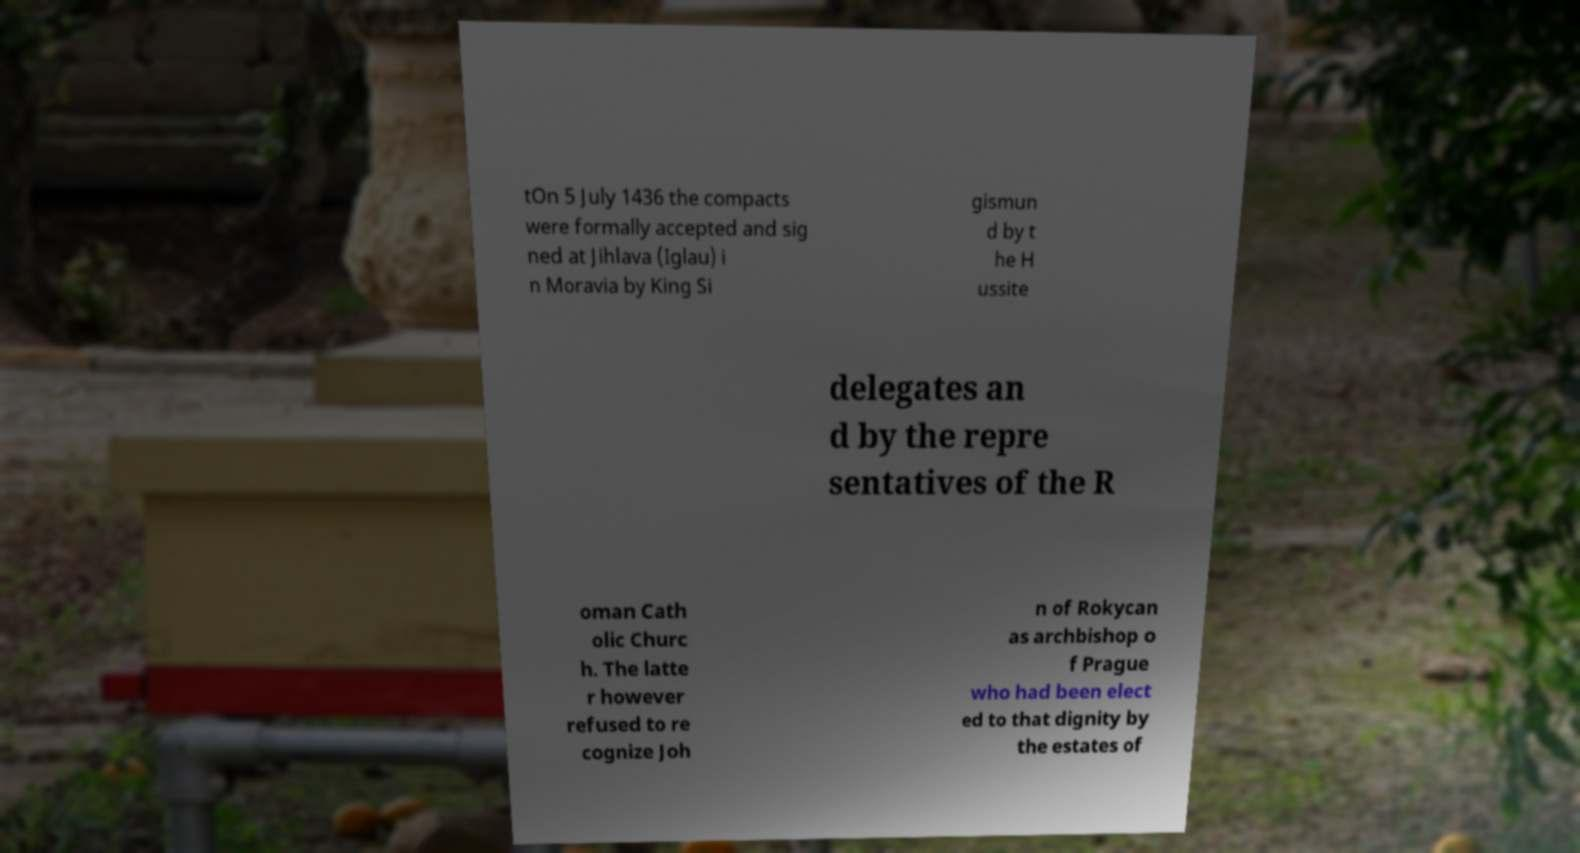I need the written content from this picture converted into text. Can you do that? tOn 5 July 1436 the compacts were formally accepted and sig ned at Jihlava (Iglau) i n Moravia by King Si gismun d by t he H ussite delegates an d by the repre sentatives of the R oman Cath olic Churc h. The latte r however refused to re cognize Joh n of Rokycan as archbishop o f Prague who had been elect ed to that dignity by the estates of 